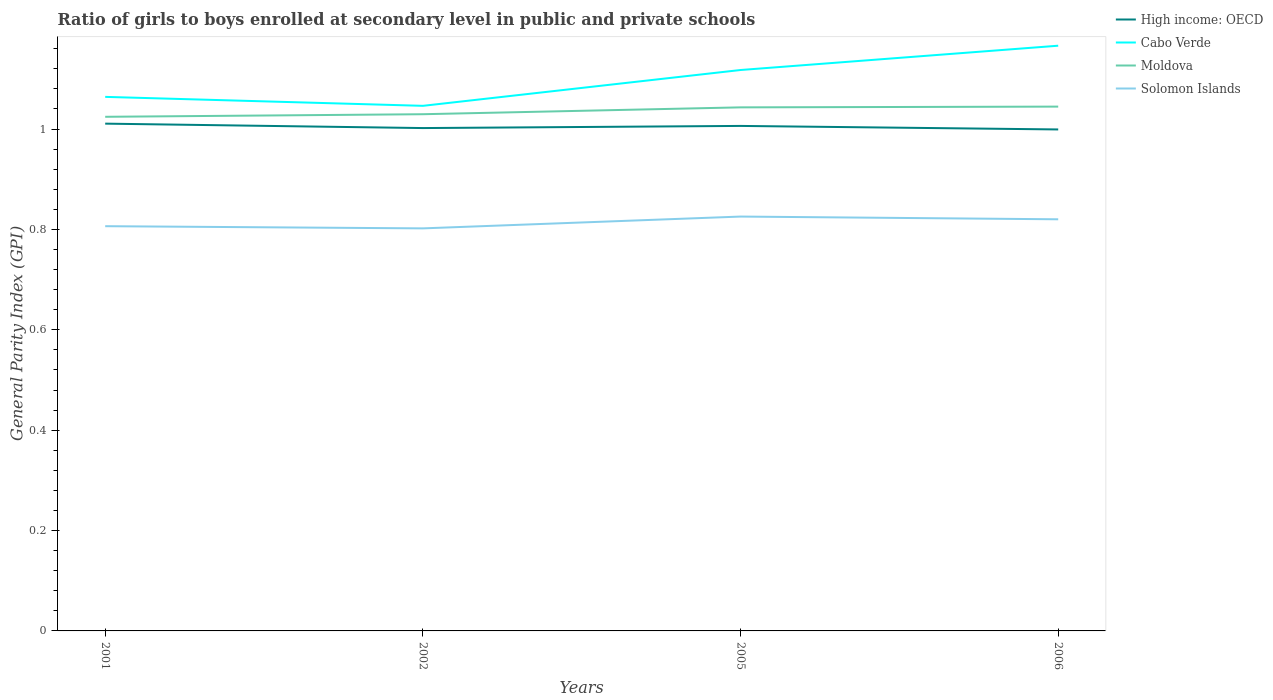Does the line corresponding to High income: OECD intersect with the line corresponding to Solomon Islands?
Keep it short and to the point. No. Across all years, what is the maximum general parity index in Cabo Verde?
Offer a terse response. 1.05. What is the total general parity index in Moldova in the graph?
Ensure brevity in your answer.  -0.01. What is the difference between the highest and the second highest general parity index in Cabo Verde?
Give a very brief answer. 0.12. What is the difference between the highest and the lowest general parity index in Cabo Verde?
Give a very brief answer. 2. How many years are there in the graph?
Your answer should be very brief. 4. How many legend labels are there?
Your response must be concise. 4. How are the legend labels stacked?
Your answer should be compact. Vertical. What is the title of the graph?
Your answer should be compact. Ratio of girls to boys enrolled at secondary level in public and private schools. What is the label or title of the Y-axis?
Your response must be concise. General Parity Index (GPI). What is the General Parity Index (GPI) in High income: OECD in 2001?
Make the answer very short. 1.01. What is the General Parity Index (GPI) of Cabo Verde in 2001?
Offer a very short reply. 1.06. What is the General Parity Index (GPI) of Moldova in 2001?
Your answer should be very brief. 1.02. What is the General Parity Index (GPI) in Solomon Islands in 2001?
Give a very brief answer. 0.81. What is the General Parity Index (GPI) in High income: OECD in 2002?
Your response must be concise. 1. What is the General Parity Index (GPI) of Cabo Verde in 2002?
Offer a very short reply. 1.05. What is the General Parity Index (GPI) in Moldova in 2002?
Offer a very short reply. 1.03. What is the General Parity Index (GPI) in Solomon Islands in 2002?
Offer a terse response. 0.8. What is the General Parity Index (GPI) in High income: OECD in 2005?
Your answer should be very brief. 1.01. What is the General Parity Index (GPI) in Cabo Verde in 2005?
Provide a short and direct response. 1.12. What is the General Parity Index (GPI) of Moldova in 2005?
Provide a short and direct response. 1.04. What is the General Parity Index (GPI) of Solomon Islands in 2005?
Ensure brevity in your answer.  0.83. What is the General Parity Index (GPI) in High income: OECD in 2006?
Provide a short and direct response. 1. What is the General Parity Index (GPI) in Cabo Verde in 2006?
Keep it short and to the point. 1.17. What is the General Parity Index (GPI) of Moldova in 2006?
Ensure brevity in your answer.  1.04. What is the General Parity Index (GPI) of Solomon Islands in 2006?
Keep it short and to the point. 0.82. Across all years, what is the maximum General Parity Index (GPI) of High income: OECD?
Offer a terse response. 1.01. Across all years, what is the maximum General Parity Index (GPI) of Cabo Verde?
Give a very brief answer. 1.17. Across all years, what is the maximum General Parity Index (GPI) of Moldova?
Provide a short and direct response. 1.04. Across all years, what is the maximum General Parity Index (GPI) of Solomon Islands?
Offer a terse response. 0.83. Across all years, what is the minimum General Parity Index (GPI) in High income: OECD?
Offer a terse response. 1. Across all years, what is the minimum General Parity Index (GPI) of Cabo Verde?
Your answer should be very brief. 1.05. Across all years, what is the minimum General Parity Index (GPI) of Moldova?
Your answer should be very brief. 1.02. Across all years, what is the minimum General Parity Index (GPI) of Solomon Islands?
Provide a succinct answer. 0.8. What is the total General Parity Index (GPI) of High income: OECD in the graph?
Your answer should be compact. 4.02. What is the total General Parity Index (GPI) of Cabo Verde in the graph?
Your response must be concise. 4.39. What is the total General Parity Index (GPI) of Moldova in the graph?
Ensure brevity in your answer.  4.14. What is the total General Parity Index (GPI) of Solomon Islands in the graph?
Provide a succinct answer. 3.25. What is the difference between the General Parity Index (GPI) of High income: OECD in 2001 and that in 2002?
Your answer should be very brief. 0.01. What is the difference between the General Parity Index (GPI) of Cabo Verde in 2001 and that in 2002?
Ensure brevity in your answer.  0.02. What is the difference between the General Parity Index (GPI) in Moldova in 2001 and that in 2002?
Keep it short and to the point. -0.01. What is the difference between the General Parity Index (GPI) in Solomon Islands in 2001 and that in 2002?
Make the answer very short. 0. What is the difference between the General Parity Index (GPI) of High income: OECD in 2001 and that in 2005?
Provide a succinct answer. 0. What is the difference between the General Parity Index (GPI) in Cabo Verde in 2001 and that in 2005?
Provide a succinct answer. -0.05. What is the difference between the General Parity Index (GPI) of Moldova in 2001 and that in 2005?
Provide a succinct answer. -0.02. What is the difference between the General Parity Index (GPI) of Solomon Islands in 2001 and that in 2005?
Give a very brief answer. -0.02. What is the difference between the General Parity Index (GPI) of High income: OECD in 2001 and that in 2006?
Your response must be concise. 0.01. What is the difference between the General Parity Index (GPI) in Cabo Verde in 2001 and that in 2006?
Provide a succinct answer. -0.1. What is the difference between the General Parity Index (GPI) of Moldova in 2001 and that in 2006?
Your response must be concise. -0.02. What is the difference between the General Parity Index (GPI) of Solomon Islands in 2001 and that in 2006?
Offer a terse response. -0.01. What is the difference between the General Parity Index (GPI) of High income: OECD in 2002 and that in 2005?
Provide a short and direct response. -0. What is the difference between the General Parity Index (GPI) in Cabo Verde in 2002 and that in 2005?
Offer a terse response. -0.07. What is the difference between the General Parity Index (GPI) in Moldova in 2002 and that in 2005?
Keep it short and to the point. -0.01. What is the difference between the General Parity Index (GPI) of Solomon Islands in 2002 and that in 2005?
Offer a terse response. -0.02. What is the difference between the General Parity Index (GPI) of High income: OECD in 2002 and that in 2006?
Provide a succinct answer. 0. What is the difference between the General Parity Index (GPI) of Cabo Verde in 2002 and that in 2006?
Make the answer very short. -0.12. What is the difference between the General Parity Index (GPI) of Moldova in 2002 and that in 2006?
Provide a succinct answer. -0.02. What is the difference between the General Parity Index (GPI) in Solomon Islands in 2002 and that in 2006?
Your answer should be very brief. -0.02. What is the difference between the General Parity Index (GPI) in High income: OECD in 2005 and that in 2006?
Offer a terse response. 0.01. What is the difference between the General Parity Index (GPI) of Cabo Verde in 2005 and that in 2006?
Your answer should be very brief. -0.05. What is the difference between the General Parity Index (GPI) of Moldova in 2005 and that in 2006?
Give a very brief answer. -0. What is the difference between the General Parity Index (GPI) in Solomon Islands in 2005 and that in 2006?
Give a very brief answer. 0.01. What is the difference between the General Parity Index (GPI) in High income: OECD in 2001 and the General Parity Index (GPI) in Cabo Verde in 2002?
Give a very brief answer. -0.04. What is the difference between the General Parity Index (GPI) in High income: OECD in 2001 and the General Parity Index (GPI) in Moldova in 2002?
Provide a succinct answer. -0.02. What is the difference between the General Parity Index (GPI) of High income: OECD in 2001 and the General Parity Index (GPI) of Solomon Islands in 2002?
Your answer should be compact. 0.21. What is the difference between the General Parity Index (GPI) of Cabo Verde in 2001 and the General Parity Index (GPI) of Moldova in 2002?
Give a very brief answer. 0.03. What is the difference between the General Parity Index (GPI) of Cabo Verde in 2001 and the General Parity Index (GPI) of Solomon Islands in 2002?
Provide a short and direct response. 0.26. What is the difference between the General Parity Index (GPI) of Moldova in 2001 and the General Parity Index (GPI) of Solomon Islands in 2002?
Provide a short and direct response. 0.22. What is the difference between the General Parity Index (GPI) of High income: OECD in 2001 and the General Parity Index (GPI) of Cabo Verde in 2005?
Make the answer very short. -0.11. What is the difference between the General Parity Index (GPI) of High income: OECD in 2001 and the General Parity Index (GPI) of Moldova in 2005?
Your answer should be compact. -0.03. What is the difference between the General Parity Index (GPI) of High income: OECD in 2001 and the General Parity Index (GPI) of Solomon Islands in 2005?
Give a very brief answer. 0.19. What is the difference between the General Parity Index (GPI) in Cabo Verde in 2001 and the General Parity Index (GPI) in Moldova in 2005?
Offer a terse response. 0.02. What is the difference between the General Parity Index (GPI) of Cabo Verde in 2001 and the General Parity Index (GPI) of Solomon Islands in 2005?
Your response must be concise. 0.24. What is the difference between the General Parity Index (GPI) in Moldova in 2001 and the General Parity Index (GPI) in Solomon Islands in 2005?
Your answer should be very brief. 0.2. What is the difference between the General Parity Index (GPI) in High income: OECD in 2001 and the General Parity Index (GPI) in Cabo Verde in 2006?
Make the answer very short. -0.16. What is the difference between the General Parity Index (GPI) of High income: OECD in 2001 and the General Parity Index (GPI) of Moldova in 2006?
Your response must be concise. -0.03. What is the difference between the General Parity Index (GPI) of High income: OECD in 2001 and the General Parity Index (GPI) of Solomon Islands in 2006?
Provide a short and direct response. 0.19. What is the difference between the General Parity Index (GPI) in Cabo Verde in 2001 and the General Parity Index (GPI) in Moldova in 2006?
Ensure brevity in your answer.  0.02. What is the difference between the General Parity Index (GPI) of Cabo Verde in 2001 and the General Parity Index (GPI) of Solomon Islands in 2006?
Make the answer very short. 0.24. What is the difference between the General Parity Index (GPI) in Moldova in 2001 and the General Parity Index (GPI) in Solomon Islands in 2006?
Give a very brief answer. 0.2. What is the difference between the General Parity Index (GPI) in High income: OECD in 2002 and the General Parity Index (GPI) in Cabo Verde in 2005?
Offer a terse response. -0.12. What is the difference between the General Parity Index (GPI) of High income: OECD in 2002 and the General Parity Index (GPI) of Moldova in 2005?
Give a very brief answer. -0.04. What is the difference between the General Parity Index (GPI) of High income: OECD in 2002 and the General Parity Index (GPI) of Solomon Islands in 2005?
Your answer should be compact. 0.18. What is the difference between the General Parity Index (GPI) in Cabo Verde in 2002 and the General Parity Index (GPI) in Moldova in 2005?
Ensure brevity in your answer.  0. What is the difference between the General Parity Index (GPI) in Cabo Verde in 2002 and the General Parity Index (GPI) in Solomon Islands in 2005?
Give a very brief answer. 0.22. What is the difference between the General Parity Index (GPI) in Moldova in 2002 and the General Parity Index (GPI) in Solomon Islands in 2005?
Offer a terse response. 0.2. What is the difference between the General Parity Index (GPI) of High income: OECD in 2002 and the General Parity Index (GPI) of Cabo Verde in 2006?
Offer a terse response. -0.16. What is the difference between the General Parity Index (GPI) of High income: OECD in 2002 and the General Parity Index (GPI) of Moldova in 2006?
Your response must be concise. -0.04. What is the difference between the General Parity Index (GPI) in High income: OECD in 2002 and the General Parity Index (GPI) in Solomon Islands in 2006?
Keep it short and to the point. 0.18. What is the difference between the General Parity Index (GPI) of Cabo Verde in 2002 and the General Parity Index (GPI) of Moldova in 2006?
Your answer should be very brief. 0. What is the difference between the General Parity Index (GPI) in Cabo Verde in 2002 and the General Parity Index (GPI) in Solomon Islands in 2006?
Your response must be concise. 0.23. What is the difference between the General Parity Index (GPI) of Moldova in 2002 and the General Parity Index (GPI) of Solomon Islands in 2006?
Keep it short and to the point. 0.21. What is the difference between the General Parity Index (GPI) of High income: OECD in 2005 and the General Parity Index (GPI) of Cabo Verde in 2006?
Your response must be concise. -0.16. What is the difference between the General Parity Index (GPI) in High income: OECD in 2005 and the General Parity Index (GPI) in Moldova in 2006?
Your answer should be very brief. -0.04. What is the difference between the General Parity Index (GPI) of High income: OECD in 2005 and the General Parity Index (GPI) of Solomon Islands in 2006?
Offer a terse response. 0.19. What is the difference between the General Parity Index (GPI) in Cabo Verde in 2005 and the General Parity Index (GPI) in Moldova in 2006?
Your response must be concise. 0.07. What is the difference between the General Parity Index (GPI) of Cabo Verde in 2005 and the General Parity Index (GPI) of Solomon Islands in 2006?
Keep it short and to the point. 0.3. What is the difference between the General Parity Index (GPI) of Moldova in 2005 and the General Parity Index (GPI) of Solomon Islands in 2006?
Keep it short and to the point. 0.22. What is the average General Parity Index (GPI) of Cabo Verde per year?
Keep it short and to the point. 1.1. What is the average General Parity Index (GPI) of Moldova per year?
Keep it short and to the point. 1.04. What is the average General Parity Index (GPI) in Solomon Islands per year?
Ensure brevity in your answer.  0.81. In the year 2001, what is the difference between the General Parity Index (GPI) in High income: OECD and General Parity Index (GPI) in Cabo Verde?
Ensure brevity in your answer.  -0.05. In the year 2001, what is the difference between the General Parity Index (GPI) of High income: OECD and General Parity Index (GPI) of Moldova?
Your response must be concise. -0.01. In the year 2001, what is the difference between the General Parity Index (GPI) in High income: OECD and General Parity Index (GPI) in Solomon Islands?
Your answer should be very brief. 0.2. In the year 2001, what is the difference between the General Parity Index (GPI) of Cabo Verde and General Parity Index (GPI) of Moldova?
Provide a short and direct response. 0.04. In the year 2001, what is the difference between the General Parity Index (GPI) of Cabo Verde and General Parity Index (GPI) of Solomon Islands?
Provide a short and direct response. 0.26. In the year 2001, what is the difference between the General Parity Index (GPI) in Moldova and General Parity Index (GPI) in Solomon Islands?
Your answer should be compact. 0.22. In the year 2002, what is the difference between the General Parity Index (GPI) in High income: OECD and General Parity Index (GPI) in Cabo Verde?
Offer a terse response. -0.04. In the year 2002, what is the difference between the General Parity Index (GPI) of High income: OECD and General Parity Index (GPI) of Moldova?
Your response must be concise. -0.03. In the year 2002, what is the difference between the General Parity Index (GPI) in High income: OECD and General Parity Index (GPI) in Solomon Islands?
Ensure brevity in your answer.  0.2. In the year 2002, what is the difference between the General Parity Index (GPI) in Cabo Verde and General Parity Index (GPI) in Moldova?
Offer a very short reply. 0.02. In the year 2002, what is the difference between the General Parity Index (GPI) of Cabo Verde and General Parity Index (GPI) of Solomon Islands?
Make the answer very short. 0.24. In the year 2002, what is the difference between the General Parity Index (GPI) in Moldova and General Parity Index (GPI) in Solomon Islands?
Keep it short and to the point. 0.23. In the year 2005, what is the difference between the General Parity Index (GPI) of High income: OECD and General Parity Index (GPI) of Cabo Verde?
Your answer should be very brief. -0.11. In the year 2005, what is the difference between the General Parity Index (GPI) of High income: OECD and General Parity Index (GPI) of Moldova?
Offer a terse response. -0.04. In the year 2005, what is the difference between the General Parity Index (GPI) of High income: OECD and General Parity Index (GPI) of Solomon Islands?
Keep it short and to the point. 0.18. In the year 2005, what is the difference between the General Parity Index (GPI) in Cabo Verde and General Parity Index (GPI) in Moldova?
Make the answer very short. 0.07. In the year 2005, what is the difference between the General Parity Index (GPI) of Cabo Verde and General Parity Index (GPI) of Solomon Islands?
Your answer should be very brief. 0.29. In the year 2005, what is the difference between the General Parity Index (GPI) in Moldova and General Parity Index (GPI) in Solomon Islands?
Your response must be concise. 0.22. In the year 2006, what is the difference between the General Parity Index (GPI) of High income: OECD and General Parity Index (GPI) of Cabo Verde?
Keep it short and to the point. -0.17. In the year 2006, what is the difference between the General Parity Index (GPI) in High income: OECD and General Parity Index (GPI) in Moldova?
Ensure brevity in your answer.  -0.05. In the year 2006, what is the difference between the General Parity Index (GPI) in High income: OECD and General Parity Index (GPI) in Solomon Islands?
Make the answer very short. 0.18. In the year 2006, what is the difference between the General Parity Index (GPI) in Cabo Verde and General Parity Index (GPI) in Moldova?
Provide a succinct answer. 0.12. In the year 2006, what is the difference between the General Parity Index (GPI) of Cabo Verde and General Parity Index (GPI) of Solomon Islands?
Provide a succinct answer. 0.35. In the year 2006, what is the difference between the General Parity Index (GPI) in Moldova and General Parity Index (GPI) in Solomon Islands?
Offer a very short reply. 0.22. What is the ratio of the General Parity Index (GPI) in High income: OECD in 2001 to that in 2002?
Provide a succinct answer. 1.01. What is the ratio of the General Parity Index (GPI) of Cabo Verde in 2001 to that in 2002?
Offer a very short reply. 1.02. What is the ratio of the General Parity Index (GPI) in Moldova in 2001 to that in 2002?
Your answer should be very brief. 0.99. What is the ratio of the General Parity Index (GPI) in Solomon Islands in 2001 to that in 2002?
Give a very brief answer. 1.01. What is the ratio of the General Parity Index (GPI) of High income: OECD in 2001 to that in 2005?
Ensure brevity in your answer.  1. What is the ratio of the General Parity Index (GPI) of Cabo Verde in 2001 to that in 2005?
Your answer should be compact. 0.95. What is the ratio of the General Parity Index (GPI) in Solomon Islands in 2001 to that in 2005?
Give a very brief answer. 0.98. What is the ratio of the General Parity Index (GPI) in High income: OECD in 2001 to that in 2006?
Your answer should be compact. 1.01. What is the ratio of the General Parity Index (GPI) of Cabo Verde in 2001 to that in 2006?
Your answer should be compact. 0.91. What is the ratio of the General Parity Index (GPI) in Moldova in 2001 to that in 2006?
Ensure brevity in your answer.  0.98. What is the ratio of the General Parity Index (GPI) in Solomon Islands in 2001 to that in 2006?
Provide a succinct answer. 0.98. What is the ratio of the General Parity Index (GPI) in Cabo Verde in 2002 to that in 2005?
Offer a very short reply. 0.94. What is the ratio of the General Parity Index (GPI) of Moldova in 2002 to that in 2005?
Make the answer very short. 0.99. What is the ratio of the General Parity Index (GPI) in Solomon Islands in 2002 to that in 2005?
Provide a succinct answer. 0.97. What is the ratio of the General Parity Index (GPI) in Cabo Verde in 2002 to that in 2006?
Ensure brevity in your answer.  0.9. What is the ratio of the General Parity Index (GPI) of Moldova in 2002 to that in 2006?
Keep it short and to the point. 0.99. What is the ratio of the General Parity Index (GPI) in Solomon Islands in 2002 to that in 2006?
Offer a terse response. 0.98. What is the ratio of the General Parity Index (GPI) of Cabo Verde in 2005 to that in 2006?
Make the answer very short. 0.96. What is the ratio of the General Parity Index (GPI) of Solomon Islands in 2005 to that in 2006?
Offer a terse response. 1.01. What is the difference between the highest and the second highest General Parity Index (GPI) of High income: OECD?
Ensure brevity in your answer.  0. What is the difference between the highest and the second highest General Parity Index (GPI) in Cabo Verde?
Provide a succinct answer. 0.05. What is the difference between the highest and the second highest General Parity Index (GPI) in Moldova?
Provide a short and direct response. 0. What is the difference between the highest and the second highest General Parity Index (GPI) of Solomon Islands?
Offer a terse response. 0.01. What is the difference between the highest and the lowest General Parity Index (GPI) of High income: OECD?
Offer a terse response. 0.01. What is the difference between the highest and the lowest General Parity Index (GPI) of Cabo Verde?
Offer a terse response. 0.12. What is the difference between the highest and the lowest General Parity Index (GPI) in Moldova?
Your response must be concise. 0.02. What is the difference between the highest and the lowest General Parity Index (GPI) of Solomon Islands?
Your response must be concise. 0.02. 